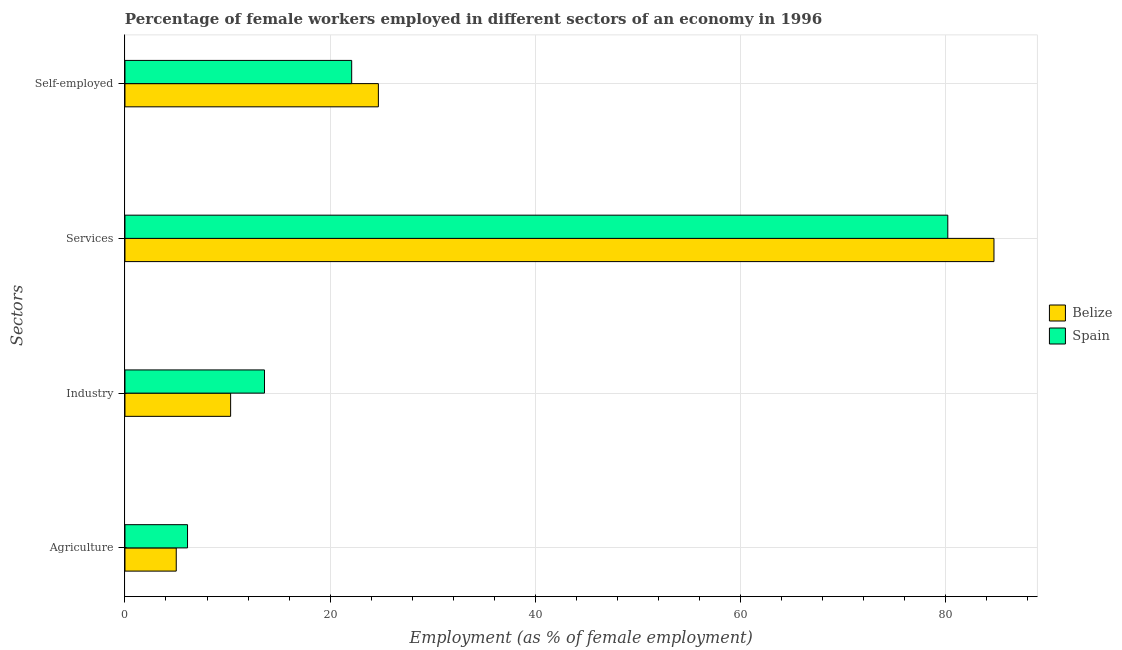Are the number of bars per tick equal to the number of legend labels?
Offer a very short reply. Yes. Are the number of bars on each tick of the Y-axis equal?
Keep it short and to the point. Yes. How many bars are there on the 3rd tick from the top?
Give a very brief answer. 2. How many bars are there on the 2nd tick from the bottom?
Ensure brevity in your answer.  2. What is the label of the 3rd group of bars from the top?
Provide a succinct answer. Industry. What is the percentage of self employed female workers in Spain?
Offer a terse response. 22.1. Across all countries, what is the maximum percentage of female workers in agriculture?
Keep it short and to the point. 6.1. Across all countries, what is the minimum percentage of self employed female workers?
Give a very brief answer. 22.1. In which country was the percentage of female workers in agriculture minimum?
Your answer should be very brief. Belize. What is the total percentage of female workers in agriculture in the graph?
Offer a very short reply. 11.1. What is the difference between the percentage of self employed female workers in Spain and that in Belize?
Your response must be concise. -2.6. What is the difference between the percentage of female workers in services in Spain and the percentage of self employed female workers in Belize?
Provide a succinct answer. 55.5. What is the average percentage of female workers in industry per country?
Make the answer very short. 11.95. What is the difference between the percentage of female workers in industry and percentage of female workers in agriculture in Belize?
Keep it short and to the point. 5.3. What is the ratio of the percentage of female workers in industry in Spain to that in Belize?
Provide a short and direct response. 1.32. What is the difference between the highest and the second highest percentage of female workers in industry?
Your response must be concise. 3.3. What is the difference between the highest and the lowest percentage of female workers in agriculture?
Keep it short and to the point. 1.1. What does the 1st bar from the bottom in Self-employed represents?
Provide a short and direct response. Belize. Are all the bars in the graph horizontal?
Offer a very short reply. Yes. What is the difference between two consecutive major ticks on the X-axis?
Your answer should be compact. 20. How are the legend labels stacked?
Provide a short and direct response. Vertical. What is the title of the graph?
Keep it short and to the point. Percentage of female workers employed in different sectors of an economy in 1996. Does "United States" appear as one of the legend labels in the graph?
Your response must be concise. No. What is the label or title of the X-axis?
Your response must be concise. Employment (as % of female employment). What is the label or title of the Y-axis?
Give a very brief answer. Sectors. What is the Employment (as % of female employment) in Spain in Agriculture?
Provide a succinct answer. 6.1. What is the Employment (as % of female employment) in Belize in Industry?
Offer a very short reply. 10.3. What is the Employment (as % of female employment) of Spain in Industry?
Your answer should be compact. 13.6. What is the Employment (as % of female employment) in Belize in Services?
Make the answer very short. 84.7. What is the Employment (as % of female employment) of Spain in Services?
Your response must be concise. 80.2. What is the Employment (as % of female employment) of Belize in Self-employed?
Give a very brief answer. 24.7. What is the Employment (as % of female employment) in Spain in Self-employed?
Provide a short and direct response. 22.1. Across all Sectors, what is the maximum Employment (as % of female employment) of Belize?
Ensure brevity in your answer.  84.7. Across all Sectors, what is the maximum Employment (as % of female employment) of Spain?
Keep it short and to the point. 80.2. Across all Sectors, what is the minimum Employment (as % of female employment) of Spain?
Provide a succinct answer. 6.1. What is the total Employment (as % of female employment) in Belize in the graph?
Keep it short and to the point. 124.7. What is the total Employment (as % of female employment) in Spain in the graph?
Offer a terse response. 122. What is the difference between the Employment (as % of female employment) of Belize in Agriculture and that in Industry?
Ensure brevity in your answer.  -5.3. What is the difference between the Employment (as % of female employment) in Belize in Agriculture and that in Services?
Ensure brevity in your answer.  -79.7. What is the difference between the Employment (as % of female employment) in Spain in Agriculture and that in Services?
Offer a very short reply. -74.1. What is the difference between the Employment (as % of female employment) of Belize in Agriculture and that in Self-employed?
Provide a short and direct response. -19.7. What is the difference between the Employment (as % of female employment) in Spain in Agriculture and that in Self-employed?
Your response must be concise. -16. What is the difference between the Employment (as % of female employment) in Belize in Industry and that in Services?
Offer a very short reply. -74.4. What is the difference between the Employment (as % of female employment) in Spain in Industry and that in Services?
Offer a very short reply. -66.6. What is the difference between the Employment (as % of female employment) of Belize in Industry and that in Self-employed?
Offer a terse response. -14.4. What is the difference between the Employment (as % of female employment) of Spain in Industry and that in Self-employed?
Provide a short and direct response. -8.5. What is the difference between the Employment (as % of female employment) of Spain in Services and that in Self-employed?
Offer a terse response. 58.1. What is the difference between the Employment (as % of female employment) of Belize in Agriculture and the Employment (as % of female employment) of Spain in Industry?
Provide a succinct answer. -8.6. What is the difference between the Employment (as % of female employment) of Belize in Agriculture and the Employment (as % of female employment) of Spain in Services?
Provide a short and direct response. -75.2. What is the difference between the Employment (as % of female employment) in Belize in Agriculture and the Employment (as % of female employment) in Spain in Self-employed?
Give a very brief answer. -17.1. What is the difference between the Employment (as % of female employment) in Belize in Industry and the Employment (as % of female employment) in Spain in Services?
Ensure brevity in your answer.  -69.9. What is the difference between the Employment (as % of female employment) in Belize in Industry and the Employment (as % of female employment) in Spain in Self-employed?
Your response must be concise. -11.8. What is the difference between the Employment (as % of female employment) in Belize in Services and the Employment (as % of female employment) in Spain in Self-employed?
Your answer should be very brief. 62.6. What is the average Employment (as % of female employment) in Belize per Sectors?
Your response must be concise. 31.18. What is the average Employment (as % of female employment) of Spain per Sectors?
Provide a short and direct response. 30.5. What is the difference between the Employment (as % of female employment) of Belize and Employment (as % of female employment) of Spain in Agriculture?
Provide a short and direct response. -1.1. What is the difference between the Employment (as % of female employment) in Belize and Employment (as % of female employment) in Spain in Industry?
Your answer should be very brief. -3.3. What is the ratio of the Employment (as % of female employment) of Belize in Agriculture to that in Industry?
Provide a succinct answer. 0.49. What is the ratio of the Employment (as % of female employment) in Spain in Agriculture to that in Industry?
Provide a succinct answer. 0.45. What is the ratio of the Employment (as % of female employment) in Belize in Agriculture to that in Services?
Ensure brevity in your answer.  0.06. What is the ratio of the Employment (as % of female employment) of Spain in Agriculture to that in Services?
Provide a short and direct response. 0.08. What is the ratio of the Employment (as % of female employment) of Belize in Agriculture to that in Self-employed?
Make the answer very short. 0.2. What is the ratio of the Employment (as % of female employment) of Spain in Agriculture to that in Self-employed?
Ensure brevity in your answer.  0.28. What is the ratio of the Employment (as % of female employment) in Belize in Industry to that in Services?
Provide a succinct answer. 0.12. What is the ratio of the Employment (as % of female employment) in Spain in Industry to that in Services?
Provide a succinct answer. 0.17. What is the ratio of the Employment (as % of female employment) of Belize in Industry to that in Self-employed?
Your answer should be compact. 0.42. What is the ratio of the Employment (as % of female employment) of Spain in Industry to that in Self-employed?
Make the answer very short. 0.62. What is the ratio of the Employment (as % of female employment) in Belize in Services to that in Self-employed?
Keep it short and to the point. 3.43. What is the ratio of the Employment (as % of female employment) in Spain in Services to that in Self-employed?
Provide a succinct answer. 3.63. What is the difference between the highest and the second highest Employment (as % of female employment) in Belize?
Provide a succinct answer. 60. What is the difference between the highest and the second highest Employment (as % of female employment) of Spain?
Offer a very short reply. 58.1. What is the difference between the highest and the lowest Employment (as % of female employment) in Belize?
Give a very brief answer. 79.7. What is the difference between the highest and the lowest Employment (as % of female employment) in Spain?
Provide a short and direct response. 74.1. 